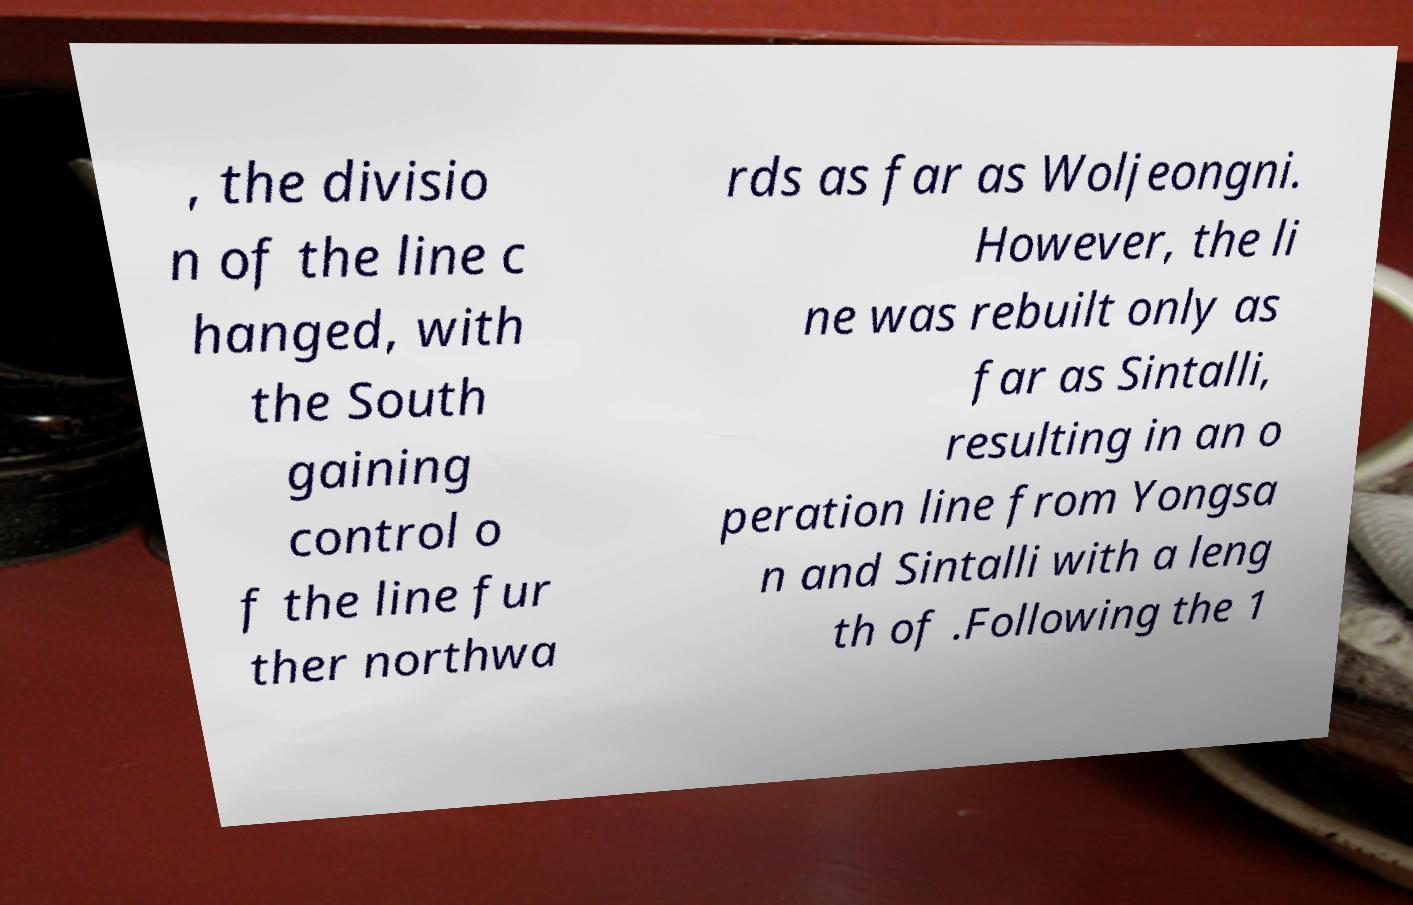What messages or text are displayed in this image? I need them in a readable, typed format. , the divisio n of the line c hanged, with the South gaining control o f the line fur ther northwa rds as far as Woljeongni. However, the li ne was rebuilt only as far as Sintalli, resulting in an o peration line from Yongsa n and Sintalli with a leng th of .Following the 1 